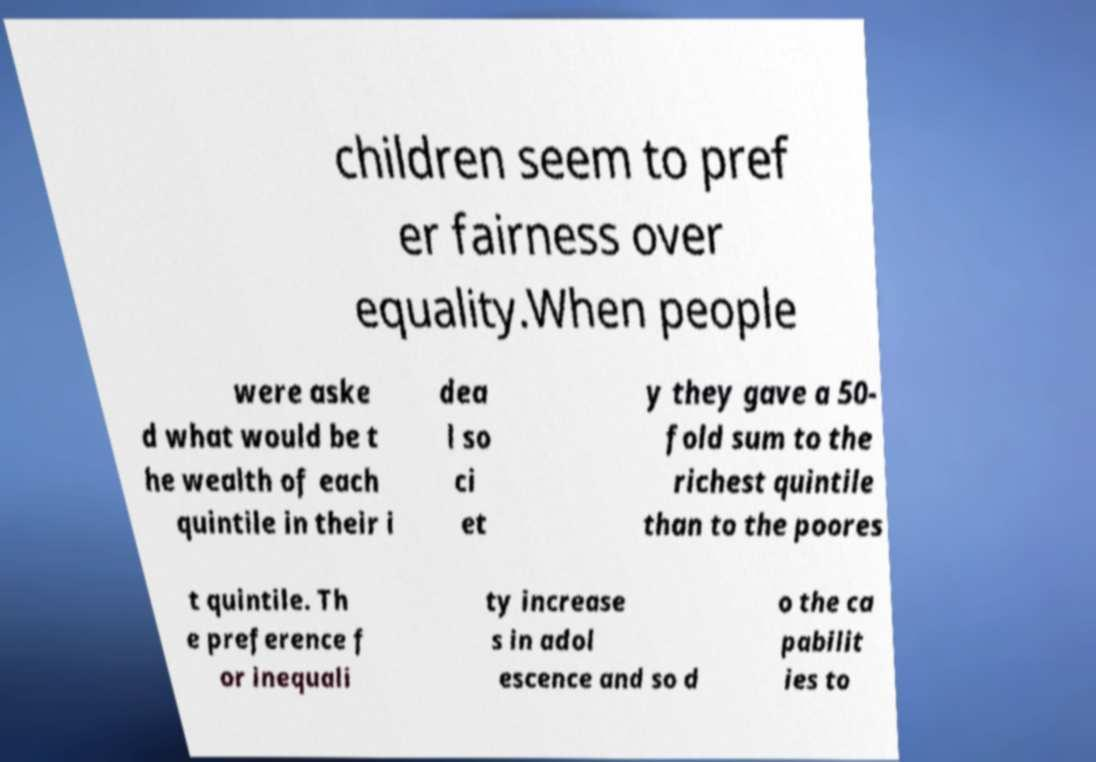Can you read and provide the text displayed in the image?This photo seems to have some interesting text. Can you extract and type it out for me? children seem to pref er fairness over equality.When people were aske d what would be t he wealth of each quintile in their i dea l so ci et y they gave a 50- fold sum to the richest quintile than to the poores t quintile. Th e preference f or inequali ty increase s in adol escence and so d o the ca pabilit ies to 